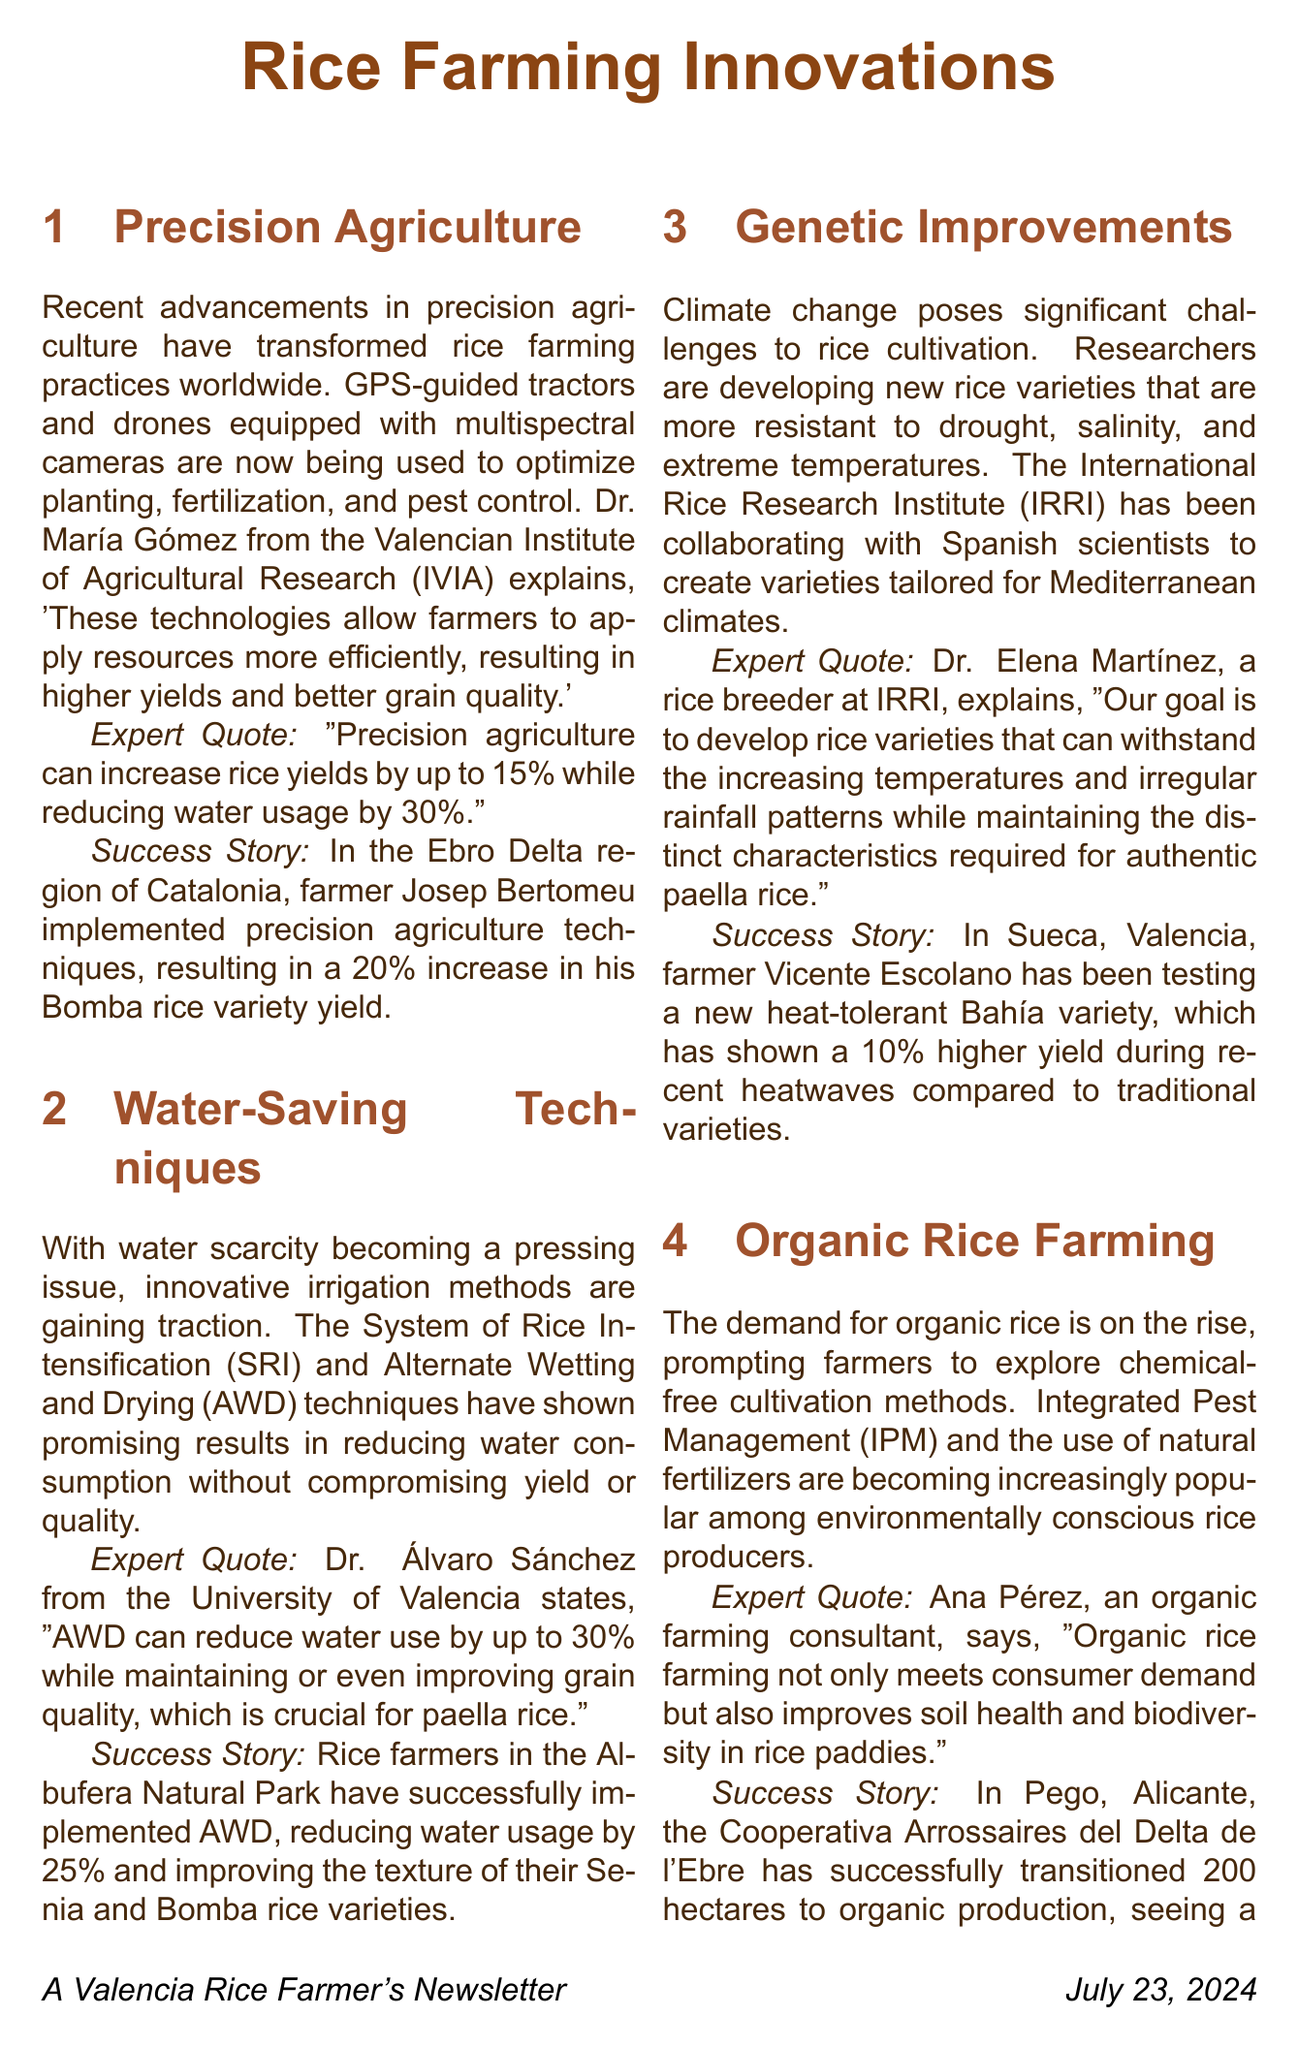What is precision agriculture? Precision agriculture involves the use of GPS-guided tractors and drones to optimize planting, fertilization, and pest control.
Answer: GPS-guided tractors and drones Who discussed the benefits of precision agriculture? Dr. María Gómez from the Valencian Institute of Agricultural Research (IVIA) explained the benefits of precision agriculture.
Answer: Dr. María Gómez What percentage increase in yield did Josep Bertomeu achieve? Josep Bertomeu implemented precision agriculture techniques resulting in a 20% increase in yield.
Answer: 20% Which water-saving technique can reduce water use by up to 30%? The Alternate Wetting and Drying (AWD) technique can reduce water use significantly.
Answer: AWD What is the main challenge addressed by genetic improvements in rice? Genetic improvements aim to tackle climate change challenges affecting rice cultivation.
Answer: Climate change What characteristic does the new Bahía variety have? The new Bahía variety is heat-tolerant.
Answer: Heat-tolerant What is the primary shift in rice farming methods mentioned in the document? The document highlights a shift towards organic farming methods.
Answer: Organic farming How much did the Cooperativa Arrossaires del Delta de l'Ebre increase their market value? The Cooperativa saw a 30% increase in market value for their organic rice.
Answer: 30% What is a benefit of integrated pest management according to the document? Integrated Pest Management is highlighted as a method to improve environmental sustainability in farming.
Answer: Improves soil health and biodiversity 